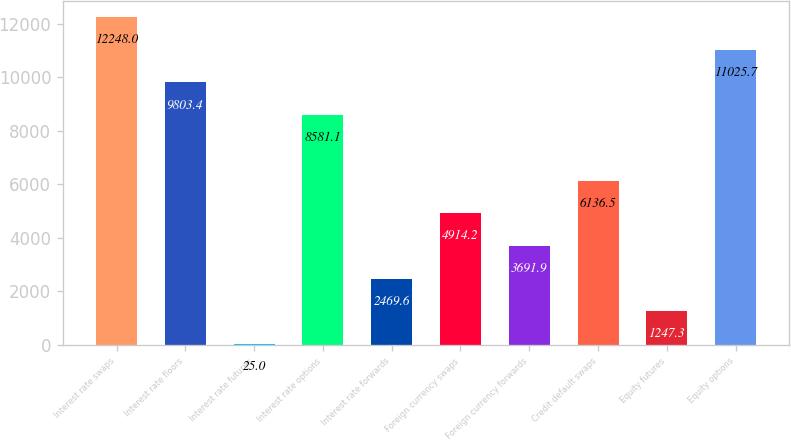Convert chart. <chart><loc_0><loc_0><loc_500><loc_500><bar_chart><fcel>Interest rate swaps<fcel>Interest rate floors<fcel>Interest rate futures<fcel>Interest rate options<fcel>Interest rate forwards<fcel>Foreign currency swaps<fcel>Foreign currency forwards<fcel>Credit default swaps<fcel>Equity futures<fcel>Equity options<nl><fcel>12248<fcel>9803.4<fcel>25<fcel>8581.1<fcel>2469.6<fcel>4914.2<fcel>3691.9<fcel>6136.5<fcel>1247.3<fcel>11025.7<nl></chart> 